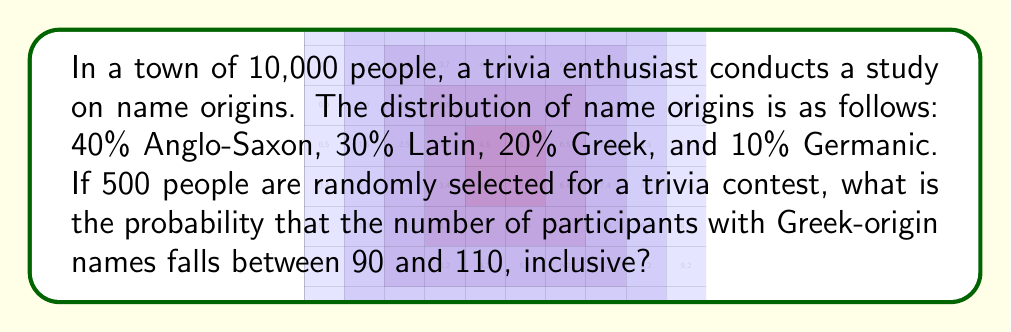Could you help me with this problem? Let's approach this step-by-step:

1) This is a binomial probability problem that can be approximated using the normal distribution due to the large sample size.

2) Let X be the number of people with Greek-origin names in the sample.

3) We know:
   n = 500 (sample size)
   p = 0.20 (probability of Greek-origin name)

4) For a binomial distribution:
   μ = np = 500 * 0.20 = 100
   σ² = np(1-p) = 500 * 0.20 * 0.80 = 80
   σ = √80 ≈ 8.944

5) We want P(90 ≤ X ≤ 110)

6) Standardizing the bounds:
   z₁ = (90 - 100) / 8.944 ≈ -1.118
   z₂ = (110 - 100) / 8.944 ≈ 1.118

7) Using the standard normal distribution:
   P(90 ≤ X ≤ 110) = P(-1.118 ≤ Z ≤ 1.118)
                   = Φ(1.118) - Φ(-1.118)
                   = Φ(1.118) - (1 - Φ(1.118))
                   = 2 * Φ(1.118) - 1

8) Using a standard normal table or calculator:
   Φ(1.118) ≈ 0.8683

9) Therefore:
   P(90 ≤ X ≤ 110) ≈ 2 * 0.8683 - 1 ≈ 0.7366
Answer: $$0.7366$$ 